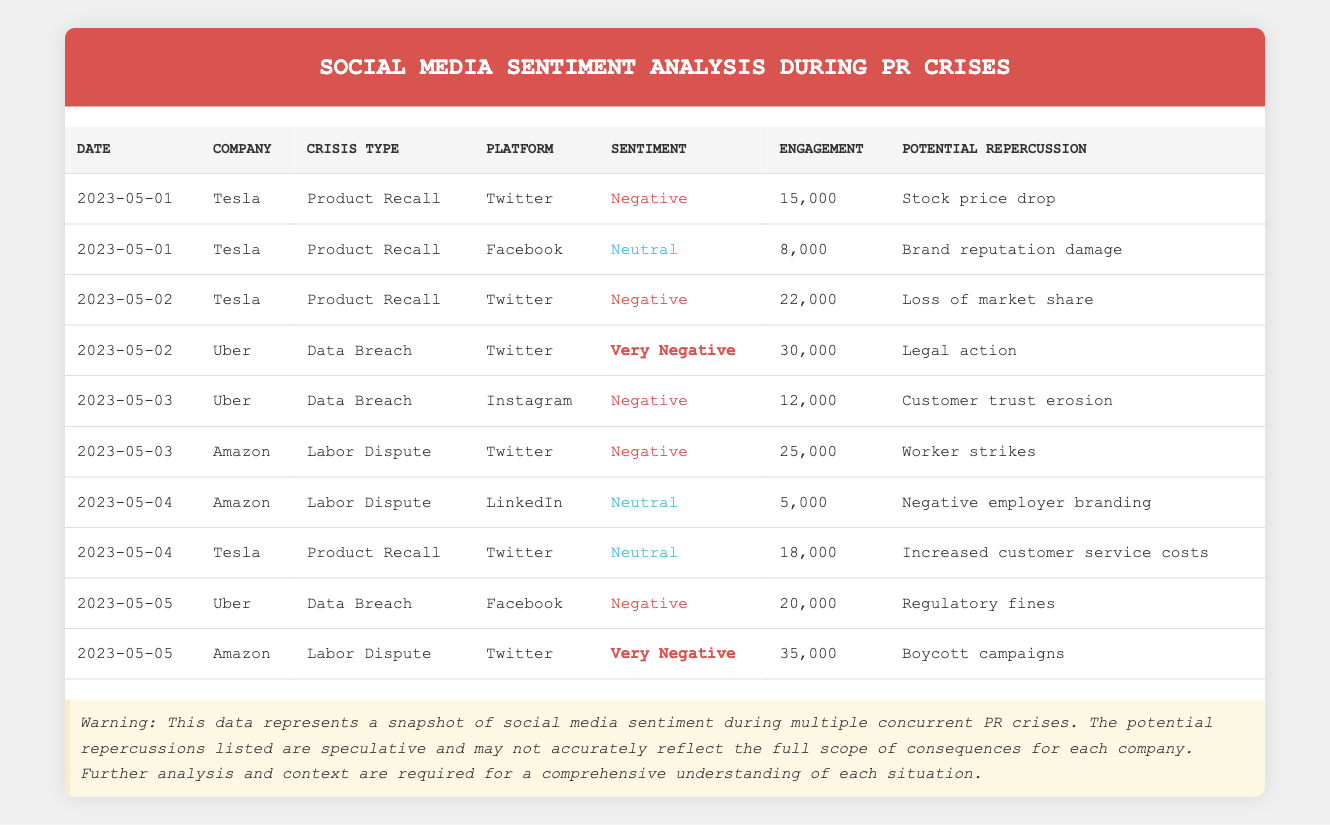What was the highest engagement on Twitter during the crises? The highest engagement on Twitter can be found by looking for the maximum value in the engagement column for the rows where the platform is Twitter. The highest engagement is 35,000 from Amazon on May 5 for the Labor Dispute.
Answer: 35,000 Which company had the most negative sentiment in total? To determine which company had the most negative sentiment, we analyze the sentiment of each company's rows and count the number of "Negative" and "Very Negative" entries. Summing these, Uber has the highest count with three instances of "Negative" and "Very Negative."
Answer: Uber Did Tesla have a negative sentiment on all platforms during the crisis? By checking Tesla's entries, we observe sentiments for Twitter (Negative), Facebook (Neutral), and Twitter again (Neutral). Since not all sentiments are negative, the answer is no.
Answer: No What is the total engagement for Amazon during its Labor Dispute? We sum the engagement for Amazon during the Labor Dispute, which includes two entries: 25,000 on Twitter and 5,000 on LinkedIn. Therefore, the total is 25,000 + 5,000 = 30,000.
Answer: 30,000 On which date did Uber experience the highest engagement? We check all Uber entries and find that the highest engagement occurs on May 2 with 30,000 engagement from Twitter.
Answer: May 2 What is the average engagement for Tesla across all its entries? Calculating Tesla's total engagement involves summing 15,000, 8,000, 22,000, 18,000, which equals 63,000. There are 4 entries, so the average is 63,000 divided by 4, giving us 15,750.
Answer: 15,750 Was there any instance of positive sentiment reported? Looking through the sentiment column, there are no entries labeled as positive; all sentiments are either negative, very negative, or neutral. Therefore, the answer is no.
Answer: No How did the engagement of the Data Breach crisis for Uber on Instagram compare to the engagement on Twitter? For Uber, the engagement on Twitter during the Data Breach was 30,000, and on Instagram, it was 12,000. Thus, Twitter's engagement is significantly higher than that on Instagram, by 18,000.
Answer: Higher by 18,000 